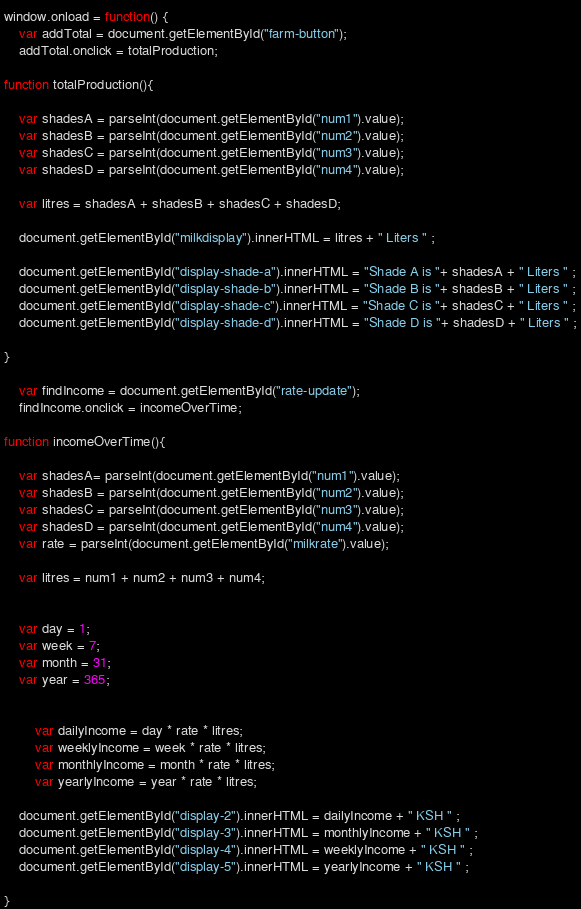<code> <loc_0><loc_0><loc_500><loc_500><_JavaScript_>window.onload = function() {
    var addTotal = document.getElementById("farm-button");
    addTotal.onclick = totalProduction;

function totalProduction(){

    var shadesA = parseInt(document.getElementById("num1").value);
    var shadesB = parseInt(document.getElementById("num2").value);
    var shadesC = parseInt(document.getElementById("num3").value);
    var shadesD = parseInt(document.getElementById("num4").value);
        
    var litres = shadesA + shadesB + shadesC + shadesD;
    
    document.getElementById("milkdisplay").innerHTML = litres + " Liters " ;

    document.getElementById("display-shade-a").innerHTML = "Shade A is "+ shadesA + " Liters " ;
    document.getElementById("display-shade-b").innerHTML = "Shade B is "+ shadesB + " Liters " ;
    document.getElementById("display-shade-c").innerHTML = "Shade C is "+ shadesC + " Liters " ;
    document.getElementById("display-shade-d").innerHTML = "Shade D is "+ shadesD + " Liters " ;

}

    var findIncome = document.getElementById("rate-update");
    findIncome.onclick = incomeOverTime;

function incomeOverTime(){

    var shadesA= parseInt(document.getElementById("num1").value);
    var shadesB = parseInt(document.getElementById("num2").value);
    var shadesC = parseInt(document.getElementById("num3").value);
    var shadesD = parseInt(document.getElementById("num4").value);
    var rate = parseInt(document.getElementById("milkrate").value);

    var litres = num1 + num2 + num3 + num4;


    var day = 1;
    var week = 7;
    var month = 31;
    var year = 365;

        
        var dailyIncome = day * rate * litres;
        var weeklyIncome = week * rate * litres;
        var monthlyIncome = month * rate * litres;
        var yearlyIncome = year * rate * litres;

    document.getElementById("display-2").innerHTML = dailyIncome + " KSH " ;
    document.getElementById("display-3").innerHTML = monthlyIncome + " KSH " ;
    document.getElementById("display-4").innerHTML = weeklyIncome + " KSH " ;
    document.getElementById("display-5").innerHTML = yearlyIncome + " KSH " ;

}</code> 